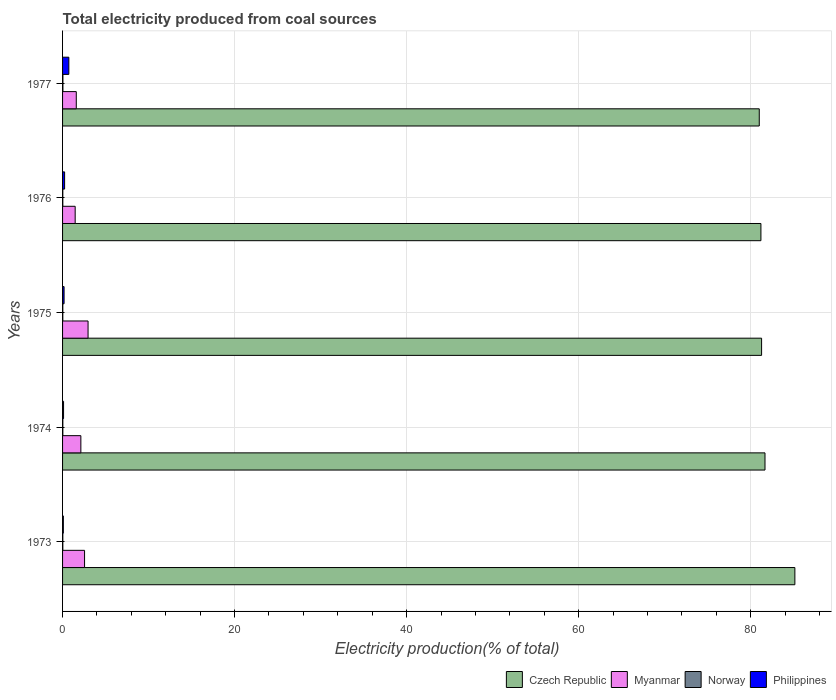How many groups of bars are there?
Offer a terse response. 5. Are the number of bars on each tick of the Y-axis equal?
Make the answer very short. Yes. How many bars are there on the 1st tick from the top?
Ensure brevity in your answer.  4. How many bars are there on the 4th tick from the bottom?
Your answer should be very brief. 4. In how many cases, is the number of bars for a given year not equal to the number of legend labels?
Offer a terse response. 0. What is the total electricity produced in Norway in 1976?
Your answer should be very brief. 0.03. Across all years, what is the maximum total electricity produced in Philippines?
Provide a succinct answer. 0.73. Across all years, what is the minimum total electricity produced in Norway?
Offer a very short reply. 0.03. In which year was the total electricity produced in Norway minimum?
Keep it short and to the point. 1976. What is the total total electricity produced in Philippines in the graph?
Make the answer very short. 1.35. What is the difference between the total electricity produced in Philippines in 1973 and that in 1974?
Offer a terse response. -0.02. What is the difference between the total electricity produced in Philippines in 1977 and the total electricity produced in Norway in 1974?
Offer a very short reply. 0.7. What is the average total electricity produced in Myanmar per year?
Keep it short and to the point. 2.14. In the year 1975, what is the difference between the total electricity produced in Czech Republic and total electricity produced in Philippines?
Give a very brief answer. 81.1. In how many years, is the total electricity produced in Norway greater than 40 %?
Your response must be concise. 0. What is the ratio of the total electricity produced in Myanmar in 1973 to that in 1976?
Give a very brief answer. 1.75. Is the total electricity produced in Philippines in 1974 less than that in 1976?
Ensure brevity in your answer.  Yes. What is the difference between the highest and the second highest total electricity produced in Czech Republic?
Provide a succinct answer. 3.47. What is the difference between the highest and the lowest total electricity produced in Czech Republic?
Your response must be concise. 4.14. Is the sum of the total electricity produced in Philippines in 1973 and 1974 greater than the maximum total electricity produced in Czech Republic across all years?
Your answer should be very brief. No. What does the 4th bar from the top in 1976 represents?
Offer a terse response. Czech Republic. What does the 1st bar from the bottom in 1975 represents?
Your response must be concise. Czech Republic. How many bars are there?
Provide a succinct answer. 20. How many years are there in the graph?
Provide a succinct answer. 5. What is the difference between two consecutive major ticks on the X-axis?
Your answer should be compact. 20. Are the values on the major ticks of X-axis written in scientific E-notation?
Offer a very short reply. No. Does the graph contain any zero values?
Provide a short and direct response. No. Does the graph contain grids?
Ensure brevity in your answer.  Yes. How are the legend labels stacked?
Your answer should be very brief. Horizontal. What is the title of the graph?
Ensure brevity in your answer.  Total electricity produced from coal sources. What is the Electricity production(% of total) of Czech Republic in 1973?
Your answer should be compact. 85.14. What is the Electricity production(% of total) in Myanmar in 1973?
Provide a short and direct response. 2.56. What is the Electricity production(% of total) in Norway in 1973?
Offer a very short reply. 0.03. What is the Electricity production(% of total) in Philippines in 1973?
Make the answer very short. 0.09. What is the Electricity production(% of total) of Czech Republic in 1974?
Ensure brevity in your answer.  81.67. What is the Electricity production(% of total) of Myanmar in 1974?
Your answer should be compact. 2.13. What is the Electricity production(% of total) of Norway in 1974?
Offer a very short reply. 0.03. What is the Electricity production(% of total) of Philippines in 1974?
Offer a terse response. 0.11. What is the Electricity production(% of total) of Czech Republic in 1975?
Provide a succinct answer. 81.27. What is the Electricity production(% of total) of Myanmar in 1975?
Keep it short and to the point. 2.97. What is the Electricity production(% of total) in Norway in 1975?
Give a very brief answer. 0.03. What is the Electricity production(% of total) in Philippines in 1975?
Your response must be concise. 0.18. What is the Electricity production(% of total) in Czech Republic in 1976?
Provide a short and direct response. 81.2. What is the Electricity production(% of total) in Myanmar in 1976?
Ensure brevity in your answer.  1.47. What is the Electricity production(% of total) in Norway in 1976?
Keep it short and to the point. 0.03. What is the Electricity production(% of total) in Philippines in 1976?
Your response must be concise. 0.24. What is the Electricity production(% of total) of Czech Republic in 1977?
Make the answer very short. 81. What is the Electricity production(% of total) of Myanmar in 1977?
Your response must be concise. 1.6. What is the Electricity production(% of total) of Norway in 1977?
Give a very brief answer. 0.04. What is the Electricity production(% of total) in Philippines in 1977?
Provide a short and direct response. 0.73. Across all years, what is the maximum Electricity production(% of total) in Czech Republic?
Keep it short and to the point. 85.14. Across all years, what is the maximum Electricity production(% of total) in Myanmar?
Provide a short and direct response. 2.97. Across all years, what is the maximum Electricity production(% of total) of Norway?
Provide a succinct answer. 0.04. Across all years, what is the maximum Electricity production(% of total) of Philippines?
Your answer should be very brief. 0.73. Across all years, what is the minimum Electricity production(% of total) in Czech Republic?
Provide a succinct answer. 81. Across all years, what is the minimum Electricity production(% of total) of Myanmar?
Your response must be concise. 1.47. Across all years, what is the minimum Electricity production(% of total) in Norway?
Make the answer very short. 0.03. Across all years, what is the minimum Electricity production(% of total) of Philippines?
Give a very brief answer. 0.09. What is the total Electricity production(% of total) in Czech Republic in the graph?
Your answer should be very brief. 410.29. What is the total Electricity production(% of total) in Myanmar in the graph?
Give a very brief answer. 10.71. What is the total Electricity production(% of total) of Norway in the graph?
Offer a terse response. 0.16. What is the total Electricity production(% of total) of Philippines in the graph?
Your answer should be compact. 1.35. What is the difference between the Electricity production(% of total) in Czech Republic in 1973 and that in 1974?
Your answer should be compact. 3.47. What is the difference between the Electricity production(% of total) of Myanmar in 1973 and that in 1974?
Give a very brief answer. 0.43. What is the difference between the Electricity production(% of total) of Norway in 1973 and that in 1974?
Provide a short and direct response. -0. What is the difference between the Electricity production(% of total) of Philippines in 1973 and that in 1974?
Offer a very short reply. -0.02. What is the difference between the Electricity production(% of total) in Czech Republic in 1973 and that in 1975?
Offer a very short reply. 3.87. What is the difference between the Electricity production(% of total) of Myanmar in 1973 and that in 1975?
Your response must be concise. -0.41. What is the difference between the Electricity production(% of total) in Norway in 1973 and that in 1975?
Your answer should be very brief. 0. What is the difference between the Electricity production(% of total) of Philippines in 1973 and that in 1975?
Keep it short and to the point. -0.08. What is the difference between the Electricity production(% of total) in Czech Republic in 1973 and that in 1976?
Make the answer very short. 3.95. What is the difference between the Electricity production(% of total) in Myanmar in 1973 and that in 1976?
Your answer should be compact. 1.09. What is the difference between the Electricity production(% of total) in Norway in 1973 and that in 1976?
Keep it short and to the point. 0. What is the difference between the Electricity production(% of total) of Philippines in 1973 and that in 1976?
Provide a short and direct response. -0.15. What is the difference between the Electricity production(% of total) in Czech Republic in 1973 and that in 1977?
Your response must be concise. 4.14. What is the difference between the Electricity production(% of total) in Myanmar in 1973 and that in 1977?
Your answer should be compact. 0.96. What is the difference between the Electricity production(% of total) in Norway in 1973 and that in 1977?
Offer a very short reply. -0.01. What is the difference between the Electricity production(% of total) of Philippines in 1973 and that in 1977?
Your answer should be compact. -0.64. What is the difference between the Electricity production(% of total) in Czech Republic in 1974 and that in 1975?
Offer a terse response. 0.4. What is the difference between the Electricity production(% of total) of Myanmar in 1974 and that in 1975?
Your answer should be very brief. -0.84. What is the difference between the Electricity production(% of total) of Norway in 1974 and that in 1975?
Your answer should be compact. 0. What is the difference between the Electricity production(% of total) in Philippines in 1974 and that in 1975?
Your answer should be compact. -0.06. What is the difference between the Electricity production(% of total) in Czech Republic in 1974 and that in 1976?
Your answer should be very brief. 0.47. What is the difference between the Electricity production(% of total) in Myanmar in 1974 and that in 1976?
Your answer should be compact. 0.66. What is the difference between the Electricity production(% of total) of Norway in 1974 and that in 1976?
Keep it short and to the point. 0. What is the difference between the Electricity production(% of total) in Philippines in 1974 and that in 1976?
Offer a terse response. -0.12. What is the difference between the Electricity production(% of total) of Czech Republic in 1974 and that in 1977?
Provide a succinct answer. 0.67. What is the difference between the Electricity production(% of total) of Myanmar in 1974 and that in 1977?
Offer a very short reply. 0.53. What is the difference between the Electricity production(% of total) of Norway in 1974 and that in 1977?
Offer a terse response. -0.01. What is the difference between the Electricity production(% of total) in Philippines in 1974 and that in 1977?
Give a very brief answer. -0.61. What is the difference between the Electricity production(% of total) in Czech Republic in 1975 and that in 1976?
Make the answer very short. 0.08. What is the difference between the Electricity production(% of total) in Philippines in 1975 and that in 1976?
Keep it short and to the point. -0.06. What is the difference between the Electricity production(% of total) in Czech Republic in 1975 and that in 1977?
Ensure brevity in your answer.  0.27. What is the difference between the Electricity production(% of total) of Myanmar in 1975 and that in 1977?
Ensure brevity in your answer.  1.37. What is the difference between the Electricity production(% of total) of Norway in 1975 and that in 1977?
Ensure brevity in your answer.  -0.01. What is the difference between the Electricity production(% of total) in Philippines in 1975 and that in 1977?
Offer a terse response. -0.55. What is the difference between the Electricity production(% of total) of Czech Republic in 1976 and that in 1977?
Give a very brief answer. 0.19. What is the difference between the Electricity production(% of total) in Myanmar in 1976 and that in 1977?
Offer a very short reply. -0.13. What is the difference between the Electricity production(% of total) in Norway in 1976 and that in 1977?
Ensure brevity in your answer.  -0.01. What is the difference between the Electricity production(% of total) of Philippines in 1976 and that in 1977?
Your answer should be compact. -0.49. What is the difference between the Electricity production(% of total) in Czech Republic in 1973 and the Electricity production(% of total) in Myanmar in 1974?
Your answer should be compact. 83.02. What is the difference between the Electricity production(% of total) of Czech Republic in 1973 and the Electricity production(% of total) of Norway in 1974?
Offer a terse response. 85.11. What is the difference between the Electricity production(% of total) of Czech Republic in 1973 and the Electricity production(% of total) of Philippines in 1974?
Your answer should be compact. 85.03. What is the difference between the Electricity production(% of total) in Myanmar in 1973 and the Electricity production(% of total) in Norway in 1974?
Ensure brevity in your answer.  2.53. What is the difference between the Electricity production(% of total) of Myanmar in 1973 and the Electricity production(% of total) of Philippines in 1974?
Ensure brevity in your answer.  2.44. What is the difference between the Electricity production(% of total) of Norway in 1973 and the Electricity production(% of total) of Philippines in 1974?
Provide a succinct answer. -0.08. What is the difference between the Electricity production(% of total) of Czech Republic in 1973 and the Electricity production(% of total) of Myanmar in 1975?
Offer a very short reply. 82.18. What is the difference between the Electricity production(% of total) in Czech Republic in 1973 and the Electricity production(% of total) in Norway in 1975?
Your answer should be compact. 85.12. What is the difference between the Electricity production(% of total) in Czech Republic in 1973 and the Electricity production(% of total) in Philippines in 1975?
Make the answer very short. 84.97. What is the difference between the Electricity production(% of total) in Myanmar in 1973 and the Electricity production(% of total) in Norway in 1975?
Keep it short and to the point. 2.53. What is the difference between the Electricity production(% of total) of Myanmar in 1973 and the Electricity production(% of total) of Philippines in 1975?
Your answer should be very brief. 2.38. What is the difference between the Electricity production(% of total) of Norway in 1973 and the Electricity production(% of total) of Philippines in 1975?
Give a very brief answer. -0.15. What is the difference between the Electricity production(% of total) in Czech Republic in 1973 and the Electricity production(% of total) in Myanmar in 1976?
Provide a short and direct response. 83.68. What is the difference between the Electricity production(% of total) of Czech Republic in 1973 and the Electricity production(% of total) of Norway in 1976?
Provide a short and direct response. 85.12. What is the difference between the Electricity production(% of total) of Czech Republic in 1973 and the Electricity production(% of total) of Philippines in 1976?
Your response must be concise. 84.91. What is the difference between the Electricity production(% of total) in Myanmar in 1973 and the Electricity production(% of total) in Norway in 1976?
Give a very brief answer. 2.53. What is the difference between the Electricity production(% of total) of Myanmar in 1973 and the Electricity production(% of total) of Philippines in 1976?
Provide a short and direct response. 2.32. What is the difference between the Electricity production(% of total) of Norway in 1973 and the Electricity production(% of total) of Philippines in 1976?
Make the answer very short. -0.21. What is the difference between the Electricity production(% of total) in Czech Republic in 1973 and the Electricity production(% of total) in Myanmar in 1977?
Provide a short and direct response. 83.55. What is the difference between the Electricity production(% of total) of Czech Republic in 1973 and the Electricity production(% of total) of Norway in 1977?
Offer a terse response. 85.1. What is the difference between the Electricity production(% of total) of Czech Republic in 1973 and the Electricity production(% of total) of Philippines in 1977?
Ensure brevity in your answer.  84.41. What is the difference between the Electricity production(% of total) in Myanmar in 1973 and the Electricity production(% of total) in Norway in 1977?
Keep it short and to the point. 2.52. What is the difference between the Electricity production(% of total) of Myanmar in 1973 and the Electricity production(% of total) of Philippines in 1977?
Your answer should be very brief. 1.83. What is the difference between the Electricity production(% of total) in Norway in 1973 and the Electricity production(% of total) in Philippines in 1977?
Your response must be concise. -0.7. What is the difference between the Electricity production(% of total) in Czech Republic in 1974 and the Electricity production(% of total) in Myanmar in 1975?
Give a very brief answer. 78.7. What is the difference between the Electricity production(% of total) in Czech Republic in 1974 and the Electricity production(% of total) in Norway in 1975?
Give a very brief answer. 81.64. What is the difference between the Electricity production(% of total) in Czech Republic in 1974 and the Electricity production(% of total) in Philippines in 1975?
Your answer should be very brief. 81.49. What is the difference between the Electricity production(% of total) in Myanmar in 1974 and the Electricity production(% of total) in Norway in 1975?
Offer a very short reply. 2.1. What is the difference between the Electricity production(% of total) in Myanmar in 1974 and the Electricity production(% of total) in Philippines in 1975?
Offer a very short reply. 1.95. What is the difference between the Electricity production(% of total) of Norway in 1974 and the Electricity production(% of total) of Philippines in 1975?
Ensure brevity in your answer.  -0.14. What is the difference between the Electricity production(% of total) of Czech Republic in 1974 and the Electricity production(% of total) of Myanmar in 1976?
Make the answer very short. 80.2. What is the difference between the Electricity production(% of total) of Czech Republic in 1974 and the Electricity production(% of total) of Norway in 1976?
Keep it short and to the point. 81.64. What is the difference between the Electricity production(% of total) in Czech Republic in 1974 and the Electricity production(% of total) in Philippines in 1976?
Provide a short and direct response. 81.43. What is the difference between the Electricity production(% of total) of Myanmar in 1974 and the Electricity production(% of total) of Norway in 1976?
Offer a very short reply. 2.1. What is the difference between the Electricity production(% of total) of Myanmar in 1974 and the Electricity production(% of total) of Philippines in 1976?
Ensure brevity in your answer.  1.89. What is the difference between the Electricity production(% of total) in Norway in 1974 and the Electricity production(% of total) in Philippines in 1976?
Provide a succinct answer. -0.21. What is the difference between the Electricity production(% of total) of Czech Republic in 1974 and the Electricity production(% of total) of Myanmar in 1977?
Ensure brevity in your answer.  80.07. What is the difference between the Electricity production(% of total) in Czech Republic in 1974 and the Electricity production(% of total) in Norway in 1977?
Make the answer very short. 81.63. What is the difference between the Electricity production(% of total) of Czech Republic in 1974 and the Electricity production(% of total) of Philippines in 1977?
Keep it short and to the point. 80.94. What is the difference between the Electricity production(% of total) in Myanmar in 1974 and the Electricity production(% of total) in Norway in 1977?
Provide a short and direct response. 2.09. What is the difference between the Electricity production(% of total) of Myanmar in 1974 and the Electricity production(% of total) of Philippines in 1977?
Make the answer very short. 1.4. What is the difference between the Electricity production(% of total) in Norway in 1974 and the Electricity production(% of total) in Philippines in 1977?
Keep it short and to the point. -0.7. What is the difference between the Electricity production(% of total) of Czech Republic in 1975 and the Electricity production(% of total) of Myanmar in 1976?
Your response must be concise. 79.81. What is the difference between the Electricity production(% of total) in Czech Republic in 1975 and the Electricity production(% of total) in Norway in 1976?
Keep it short and to the point. 81.25. What is the difference between the Electricity production(% of total) in Czech Republic in 1975 and the Electricity production(% of total) in Philippines in 1976?
Your response must be concise. 81.04. What is the difference between the Electricity production(% of total) in Myanmar in 1975 and the Electricity production(% of total) in Norway in 1976?
Ensure brevity in your answer.  2.94. What is the difference between the Electricity production(% of total) of Myanmar in 1975 and the Electricity production(% of total) of Philippines in 1976?
Your answer should be very brief. 2.73. What is the difference between the Electricity production(% of total) in Norway in 1975 and the Electricity production(% of total) in Philippines in 1976?
Ensure brevity in your answer.  -0.21. What is the difference between the Electricity production(% of total) in Czech Republic in 1975 and the Electricity production(% of total) in Myanmar in 1977?
Make the answer very short. 79.68. What is the difference between the Electricity production(% of total) in Czech Republic in 1975 and the Electricity production(% of total) in Norway in 1977?
Provide a succinct answer. 81.23. What is the difference between the Electricity production(% of total) of Czech Republic in 1975 and the Electricity production(% of total) of Philippines in 1977?
Offer a very short reply. 80.54. What is the difference between the Electricity production(% of total) in Myanmar in 1975 and the Electricity production(% of total) in Norway in 1977?
Ensure brevity in your answer.  2.92. What is the difference between the Electricity production(% of total) of Myanmar in 1975 and the Electricity production(% of total) of Philippines in 1977?
Ensure brevity in your answer.  2.24. What is the difference between the Electricity production(% of total) of Norway in 1975 and the Electricity production(% of total) of Philippines in 1977?
Offer a terse response. -0.7. What is the difference between the Electricity production(% of total) in Czech Republic in 1976 and the Electricity production(% of total) in Myanmar in 1977?
Your answer should be compact. 79.6. What is the difference between the Electricity production(% of total) of Czech Republic in 1976 and the Electricity production(% of total) of Norway in 1977?
Ensure brevity in your answer.  81.15. What is the difference between the Electricity production(% of total) of Czech Republic in 1976 and the Electricity production(% of total) of Philippines in 1977?
Offer a terse response. 80.47. What is the difference between the Electricity production(% of total) of Myanmar in 1976 and the Electricity production(% of total) of Norway in 1977?
Offer a very short reply. 1.42. What is the difference between the Electricity production(% of total) in Myanmar in 1976 and the Electricity production(% of total) in Philippines in 1977?
Offer a very short reply. 0.74. What is the difference between the Electricity production(% of total) of Norway in 1976 and the Electricity production(% of total) of Philippines in 1977?
Make the answer very short. -0.7. What is the average Electricity production(% of total) of Czech Republic per year?
Offer a terse response. 82.06. What is the average Electricity production(% of total) in Myanmar per year?
Your response must be concise. 2.14. What is the average Electricity production(% of total) in Norway per year?
Offer a very short reply. 0.03. What is the average Electricity production(% of total) in Philippines per year?
Keep it short and to the point. 0.27. In the year 1973, what is the difference between the Electricity production(% of total) in Czech Republic and Electricity production(% of total) in Myanmar?
Ensure brevity in your answer.  82.59. In the year 1973, what is the difference between the Electricity production(% of total) in Czech Republic and Electricity production(% of total) in Norway?
Give a very brief answer. 85.11. In the year 1973, what is the difference between the Electricity production(% of total) of Czech Republic and Electricity production(% of total) of Philippines?
Your answer should be very brief. 85.05. In the year 1973, what is the difference between the Electricity production(% of total) in Myanmar and Electricity production(% of total) in Norway?
Make the answer very short. 2.53. In the year 1973, what is the difference between the Electricity production(% of total) of Myanmar and Electricity production(% of total) of Philippines?
Offer a terse response. 2.47. In the year 1973, what is the difference between the Electricity production(% of total) of Norway and Electricity production(% of total) of Philippines?
Make the answer very short. -0.06. In the year 1974, what is the difference between the Electricity production(% of total) of Czech Republic and Electricity production(% of total) of Myanmar?
Make the answer very short. 79.54. In the year 1974, what is the difference between the Electricity production(% of total) in Czech Republic and Electricity production(% of total) in Norway?
Your answer should be compact. 81.64. In the year 1974, what is the difference between the Electricity production(% of total) in Czech Republic and Electricity production(% of total) in Philippines?
Your answer should be very brief. 81.55. In the year 1974, what is the difference between the Electricity production(% of total) in Myanmar and Electricity production(% of total) in Norway?
Your answer should be very brief. 2.1. In the year 1974, what is the difference between the Electricity production(% of total) of Myanmar and Electricity production(% of total) of Philippines?
Your answer should be very brief. 2.01. In the year 1974, what is the difference between the Electricity production(% of total) of Norway and Electricity production(% of total) of Philippines?
Give a very brief answer. -0.08. In the year 1975, what is the difference between the Electricity production(% of total) in Czech Republic and Electricity production(% of total) in Myanmar?
Offer a very short reply. 78.31. In the year 1975, what is the difference between the Electricity production(% of total) of Czech Republic and Electricity production(% of total) of Norway?
Give a very brief answer. 81.25. In the year 1975, what is the difference between the Electricity production(% of total) in Czech Republic and Electricity production(% of total) in Philippines?
Your answer should be compact. 81.1. In the year 1975, what is the difference between the Electricity production(% of total) in Myanmar and Electricity production(% of total) in Norway?
Your answer should be compact. 2.94. In the year 1975, what is the difference between the Electricity production(% of total) of Myanmar and Electricity production(% of total) of Philippines?
Ensure brevity in your answer.  2.79. In the year 1975, what is the difference between the Electricity production(% of total) of Norway and Electricity production(% of total) of Philippines?
Give a very brief answer. -0.15. In the year 1976, what is the difference between the Electricity production(% of total) in Czech Republic and Electricity production(% of total) in Myanmar?
Ensure brevity in your answer.  79.73. In the year 1976, what is the difference between the Electricity production(% of total) of Czech Republic and Electricity production(% of total) of Norway?
Keep it short and to the point. 81.17. In the year 1976, what is the difference between the Electricity production(% of total) in Czech Republic and Electricity production(% of total) in Philippines?
Your answer should be very brief. 80.96. In the year 1976, what is the difference between the Electricity production(% of total) in Myanmar and Electricity production(% of total) in Norway?
Make the answer very short. 1.44. In the year 1976, what is the difference between the Electricity production(% of total) in Myanmar and Electricity production(% of total) in Philippines?
Your answer should be compact. 1.23. In the year 1976, what is the difference between the Electricity production(% of total) of Norway and Electricity production(% of total) of Philippines?
Offer a very short reply. -0.21. In the year 1977, what is the difference between the Electricity production(% of total) of Czech Republic and Electricity production(% of total) of Myanmar?
Offer a terse response. 79.41. In the year 1977, what is the difference between the Electricity production(% of total) in Czech Republic and Electricity production(% of total) in Norway?
Make the answer very short. 80.96. In the year 1977, what is the difference between the Electricity production(% of total) of Czech Republic and Electricity production(% of total) of Philippines?
Offer a very short reply. 80.27. In the year 1977, what is the difference between the Electricity production(% of total) of Myanmar and Electricity production(% of total) of Norway?
Give a very brief answer. 1.55. In the year 1977, what is the difference between the Electricity production(% of total) of Myanmar and Electricity production(% of total) of Philippines?
Give a very brief answer. 0.87. In the year 1977, what is the difference between the Electricity production(% of total) of Norway and Electricity production(% of total) of Philippines?
Provide a short and direct response. -0.69. What is the ratio of the Electricity production(% of total) in Czech Republic in 1973 to that in 1974?
Provide a succinct answer. 1.04. What is the ratio of the Electricity production(% of total) in Myanmar in 1973 to that in 1974?
Offer a terse response. 1.2. What is the ratio of the Electricity production(% of total) of Norway in 1973 to that in 1974?
Provide a short and direct response. 0.92. What is the ratio of the Electricity production(% of total) of Philippines in 1973 to that in 1974?
Provide a succinct answer. 0.79. What is the ratio of the Electricity production(% of total) of Czech Republic in 1973 to that in 1975?
Give a very brief answer. 1.05. What is the ratio of the Electricity production(% of total) of Myanmar in 1973 to that in 1975?
Ensure brevity in your answer.  0.86. What is the ratio of the Electricity production(% of total) in Norway in 1973 to that in 1975?
Provide a succinct answer. 1.06. What is the ratio of the Electricity production(% of total) in Philippines in 1973 to that in 1975?
Give a very brief answer. 0.52. What is the ratio of the Electricity production(% of total) in Czech Republic in 1973 to that in 1976?
Your answer should be compact. 1.05. What is the ratio of the Electricity production(% of total) in Myanmar in 1973 to that in 1976?
Your response must be concise. 1.75. What is the ratio of the Electricity production(% of total) in Norway in 1973 to that in 1976?
Provide a short and direct response. 1.07. What is the ratio of the Electricity production(% of total) in Philippines in 1973 to that in 1976?
Provide a succinct answer. 0.38. What is the ratio of the Electricity production(% of total) of Czech Republic in 1973 to that in 1977?
Keep it short and to the point. 1.05. What is the ratio of the Electricity production(% of total) in Myanmar in 1973 to that in 1977?
Keep it short and to the point. 1.6. What is the ratio of the Electricity production(% of total) in Norway in 1973 to that in 1977?
Offer a terse response. 0.73. What is the ratio of the Electricity production(% of total) in Philippines in 1973 to that in 1977?
Your response must be concise. 0.12. What is the ratio of the Electricity production(% of total) of Czech Republic in 1974 to that in 1975?
Keep it short and to the point. 1. What is the ratio of the Electricity production(% of total) in Myanmar in 1974 to that in 1975?
Offer a very short reply. 0.72. What is the ratio of the Electricity production(% of total) in Norway in 1974 to that in 1975?
Offer a terse response. 1.15. What is the ratio of the Electricity production(% of total) of Philippines in 1974 to that in 1975?
Give a very brief answer. 0.65. What is the ratio of the Electricity production(% of total) of Czech Republic in 1974 to that in 1976?
Ensure brevity in your answer.  1.01. What is the ratio of the Electricity production(% of total) of Myanmar in 1974 to that in 1976?
Your answer should be compact. 1.45. What is the ratio of the Electricity production(% of total) of Norway in 1974 to that in 1976?
Ensure brevity in your answer.  1.16. What is the ratio of the Electricity production(% of total) of Philippines in 1974 to that in 1976?
Your answer should be compact. 0.48. What is the ratio of the Electricity production(% of total) in Czech Republic in 1974 to that in 1977?
Give a very brief answer. 1.01. What is the ratio of the Electricity production(% of total) of Myanmar in 1974 to that in 1977?
Keep it short and to the point. 1.33. What is the ratio of the Electricity production(% of total) in Norway in 1974 to that in 1977?
Ensure brevity in your answer.  0.79. What is the ratio of the Electricity production(% of total) of Philippines in 1974 to that in 1977?
Offer a very short reply. 0.16. What is the ratio of the Electricity production(% of total) in Czech Republic in 1975 to that in 1976?
Provide a short and direct response. 1. What is the ratio of the Electricity production(% of total) in Myanmar in 1975 to that in 1976?
Give a very brief answer. 2.02. What is the ratio of the Electricity production(% of total) in Norway in 1975 to that in 1976?
Your answer should be compact. 1.01. What is the ratio of the Electricity production(% of total) of Philippines in 1975 to that in 1976?
Offer a very short reply. 0.74. What is the ratio of the Electricity production(% of total) of Myanmar in 1975 to that in 1977?
Give a very brief answer. 1.86. What is the ratio of the Electricity production(% of total) of Norway in 1975 to that in 1977?
Your response must be concise. 0.68. What is the ratio of the Electricity production(% of total) in Philippines in 1975 to that in 1977?
Your response must be concise. 0.24. What is the ratio of the Electricity production(% of total) in Myanmar in 1976 to that in 1977?
Your answer should be compact. 0.92. What is the ratio of the Electricity production(% of total) of Norway in 1976 to that in 1977?
Keep it short and to the point. 0.68. What is the ratio of the Electricity production(% of total) of Philippines in 1976 to that in 1977?
Give a very brief answer. 0.33. What is the difference between the highest and the second highest Electricity production(% of total) of Czech Republic?
Provide a short and direct response. 3.47. What is the difference between the highest and the second highest Electricity production(% of total) of Myanmar?
Give a very brief answer. 0.41. What is the difference between the highest and the second highest Electricity production(% of total) of Norway?
Your answer should be very brief. 0.01. What is the difference between the highest and the second highest Electricity production(% of total) in Philippines?
Your answer should be very brief. 0.49. What is the difference between the highest and the lowest Electricity production(% of total) of Czech Republic?
Provide a short and direct response. 4.14. What is the difference between the highest and the lowest Electricity production(% of total) in Myanmar?
Ensure brevity in your answer.  1.5. What is the difference between the highest and the lowest Electricity production(% of total) in Norway?
Ensure brevity in your answer.  0.01. What is the difference between the highest and the lowest Electricity production(% of total) in Philippines?
Your answer should be compact. 0.64. 